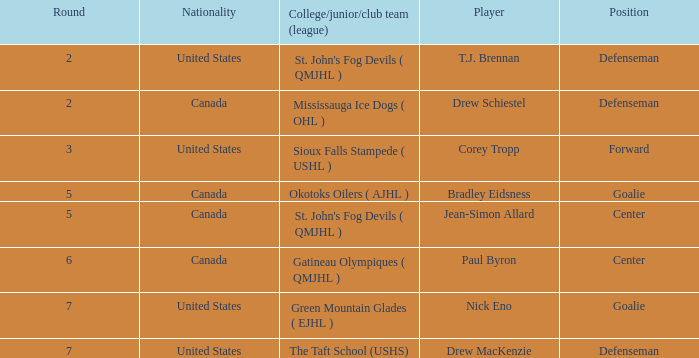What is the nationality of the goalie in Round 7? United States. 